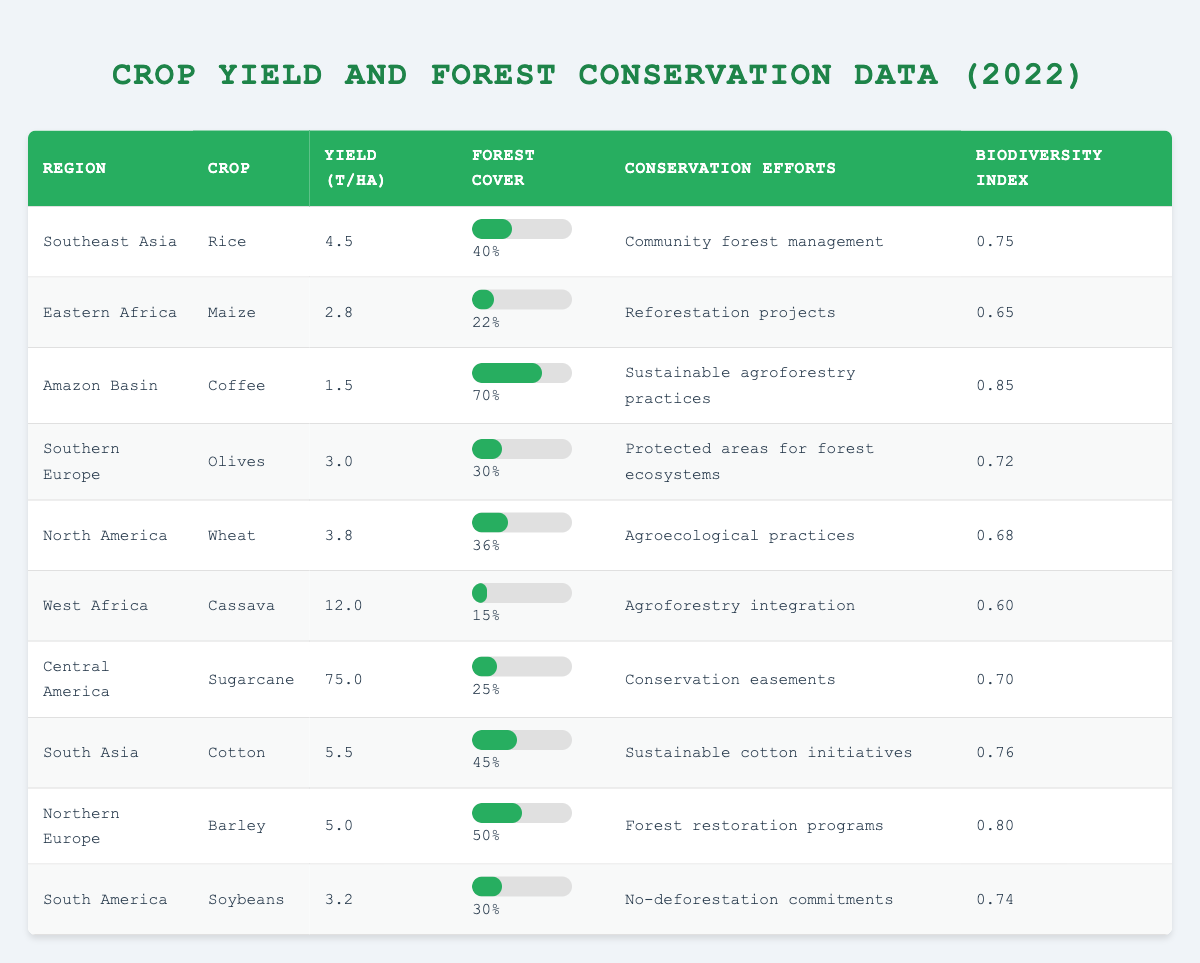What is the highest crop yield recorded and which crop does it belong to? The table lists various crop yields, with the highest yield being 75.0 tonnes per hectare for Sugarcane in Central America.
Answer: 75.0 tonnes for Sugarcane Which region has the lowest forest cover percentage? Looking at the table, West Africa has the lowest forest cover percentage at 15%.
Answer: 15% in West Africa What is the average yield per hectare across all listed regions? First, I will add all the yields: 4.5 + 2.8 + 1.5 + 3.0 + 3.8 + 12.0 + 75.0 + 5.5 + 5.0 + 3.2 = 113.3. There are 10 regions, so the average yield is 113.3 / 10 = 11.33.
Answer: 11.33 tonnes Is there a correlation between higher forest cover and crop yield in the data? To determine this, compare the forest cover percentages and crop yields. High forest cover and high yield occur in the Amazon Basin (70% and 1.5), and low yield and low forest cover in West Africa (15% and 12.0). The data show no consistent correlation.
Answer: No, no consistent correlation Which crop has the highest biodiversity index, and how does it relate to its conservation efforts? The highest biodiversity index is 0.85 for Coffee in the Amazon Basin, where sustainable agroforestry practices are in place. This suggests that effective conservation efforts can lead to higher biodiversity.
Answer: Coffee, biodiversity index 0.85 If South Asia increased its forest cover to 50%, how would that compare to Northern Europe? South Asia currently has 45% forest cover; if it increased to 50%, it would be equal to Northern Europe's forest cover of 50%.
Answer: Both would be 50% How do conservation efforts affect crop yields in high forest cover regions? By comparing the highest forest cover regions (e.g., Amazon Basin and Northern Europe), we see varying yields. Although high forest cover is associated with higher biodiversity, it does not guarantee higher crop yield, as Coffee has a low yield in the Amazon Basin.
Answer: It's mixed; higher cover doesn't ensure higher yields What region has a biodiversity index above 0.7 and what conservation efforts are being applied there? The regions with a biodiversity index above 0.7 are Southeast Asia (0.75, community forest management), South Asia (0.76, sustainable cotton initiatives), Northern Europe (0.80, forest restoration programs), and Amazon Basin (0.85, sustainable agroforestry practices).
Answer: Multiple regions Calculate the difference in crop yield per hectare between the highest and lowest values. The highest yield is 75.0 (Sugarcane) and the lowest is 1.5 (Coffee). The difference is 75.0 - 1.5 = 73.5.
Answer: 73.5 tonnes 